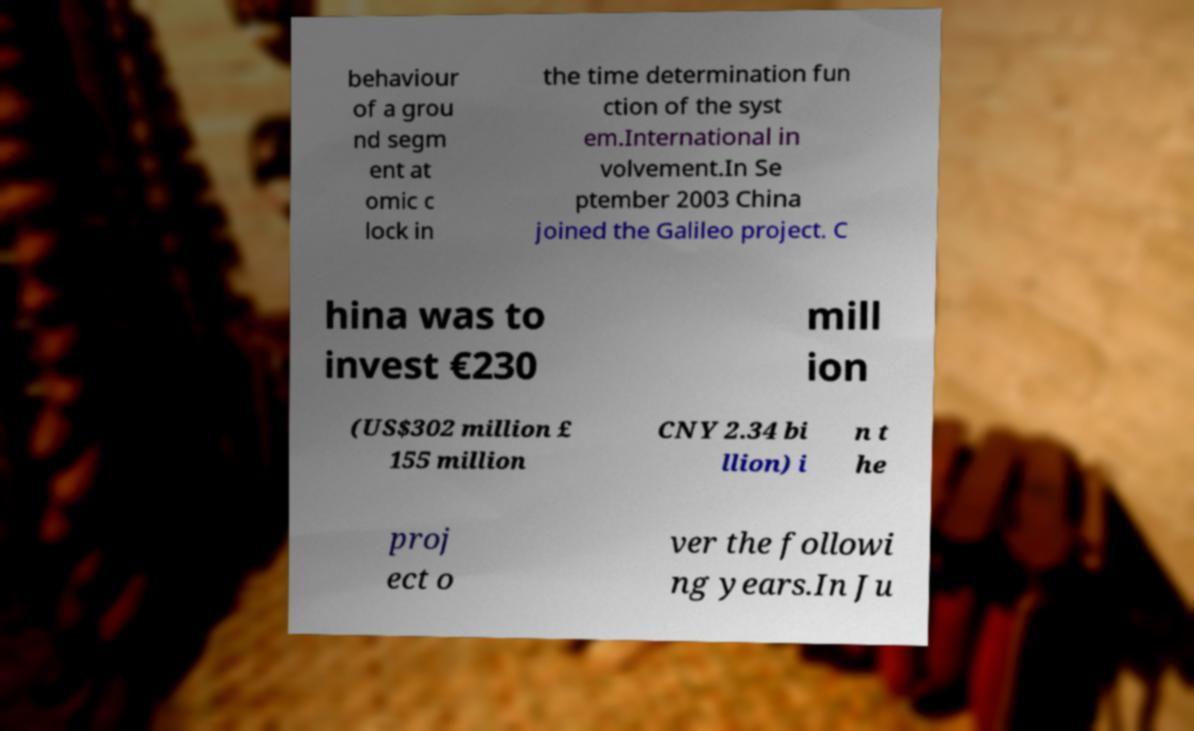Can you read and provide the text displayed in the image?This photo seems to have some interesting text. Can you extract and type it out for me? behaviour of a grou nd segm ent at omic c lock in the time determination fun ction of the syst em.International in volvement.In Se ptember 2003 China joined the Galileo project. C hina was to invest €230 mill ion (US$302 million £ 155 million CNY 2.34 bi llion) i n t he proj ect o ver the followi ng years.In Ju 